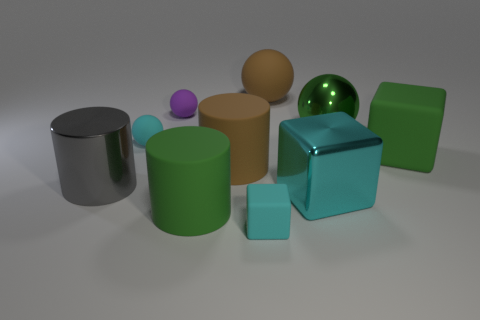Subtract all gray cylinders. How many cylinders are left? 2 Subtract all brown spheres. How many spheres are left? 3 Subtract 1 blocks. How many blocks are left? 2 Subtract all cylinders. How many objects are left? 7 Subtract all red blocks. How many yellow cylinders are left? 0 Subtract all large purple rubber cylinders. Subtract all cylinders. How many objects are left? 7 Add 3 tiny cyan matte things. How many tiny cyan matte things are left? 5 Add 1 tiny yellow metal cylinders. How many tiny yellow metal cylinders exist? 1 Subtract 1 green balls. How many objects are left? 9 Subtract all green cubes. Subtract all green cylinders. How many cubes are left? 2 